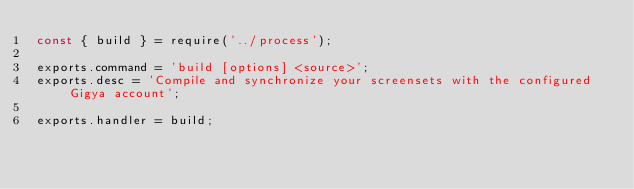<code> <loc_0><loc_0><loc_500><loc_500><_JavaScript_>const { build } = require('../process');

exports.command = 'build [options] <source>';
exports.desc = 'Compile and synchronize your screensets with the configured Gigya account';

exports.handler = build;
</code> 